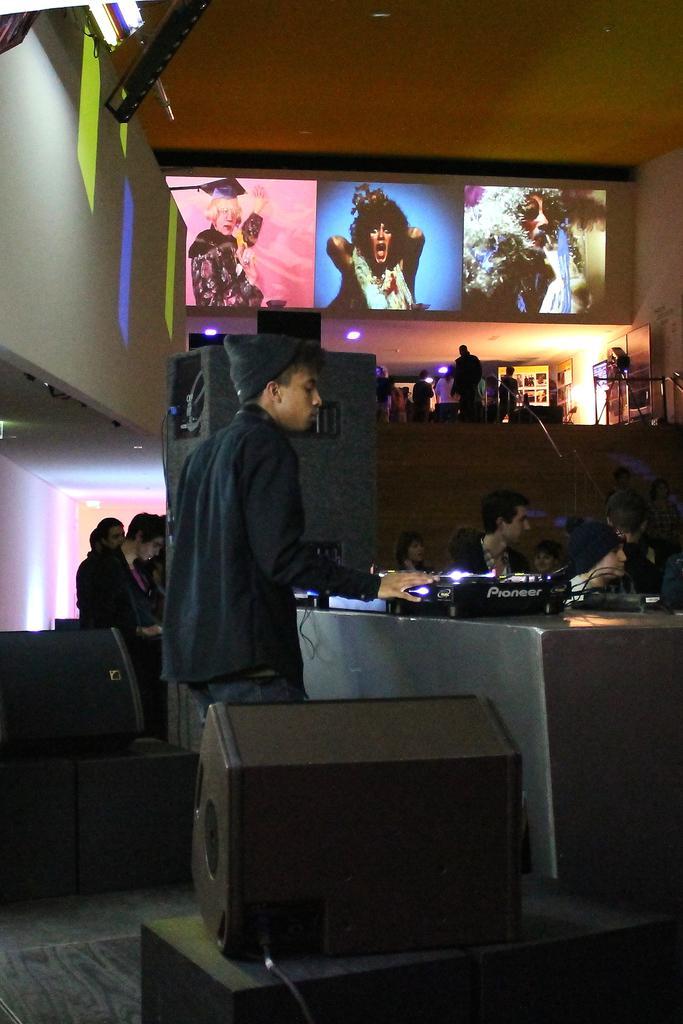How would you summarize this image in a sentence or two? This picture shows a man standing in front of a table on which some name plates and accessories were placed. In the background there are some people sitting and standing here. We can observe pictures on the wall here. 